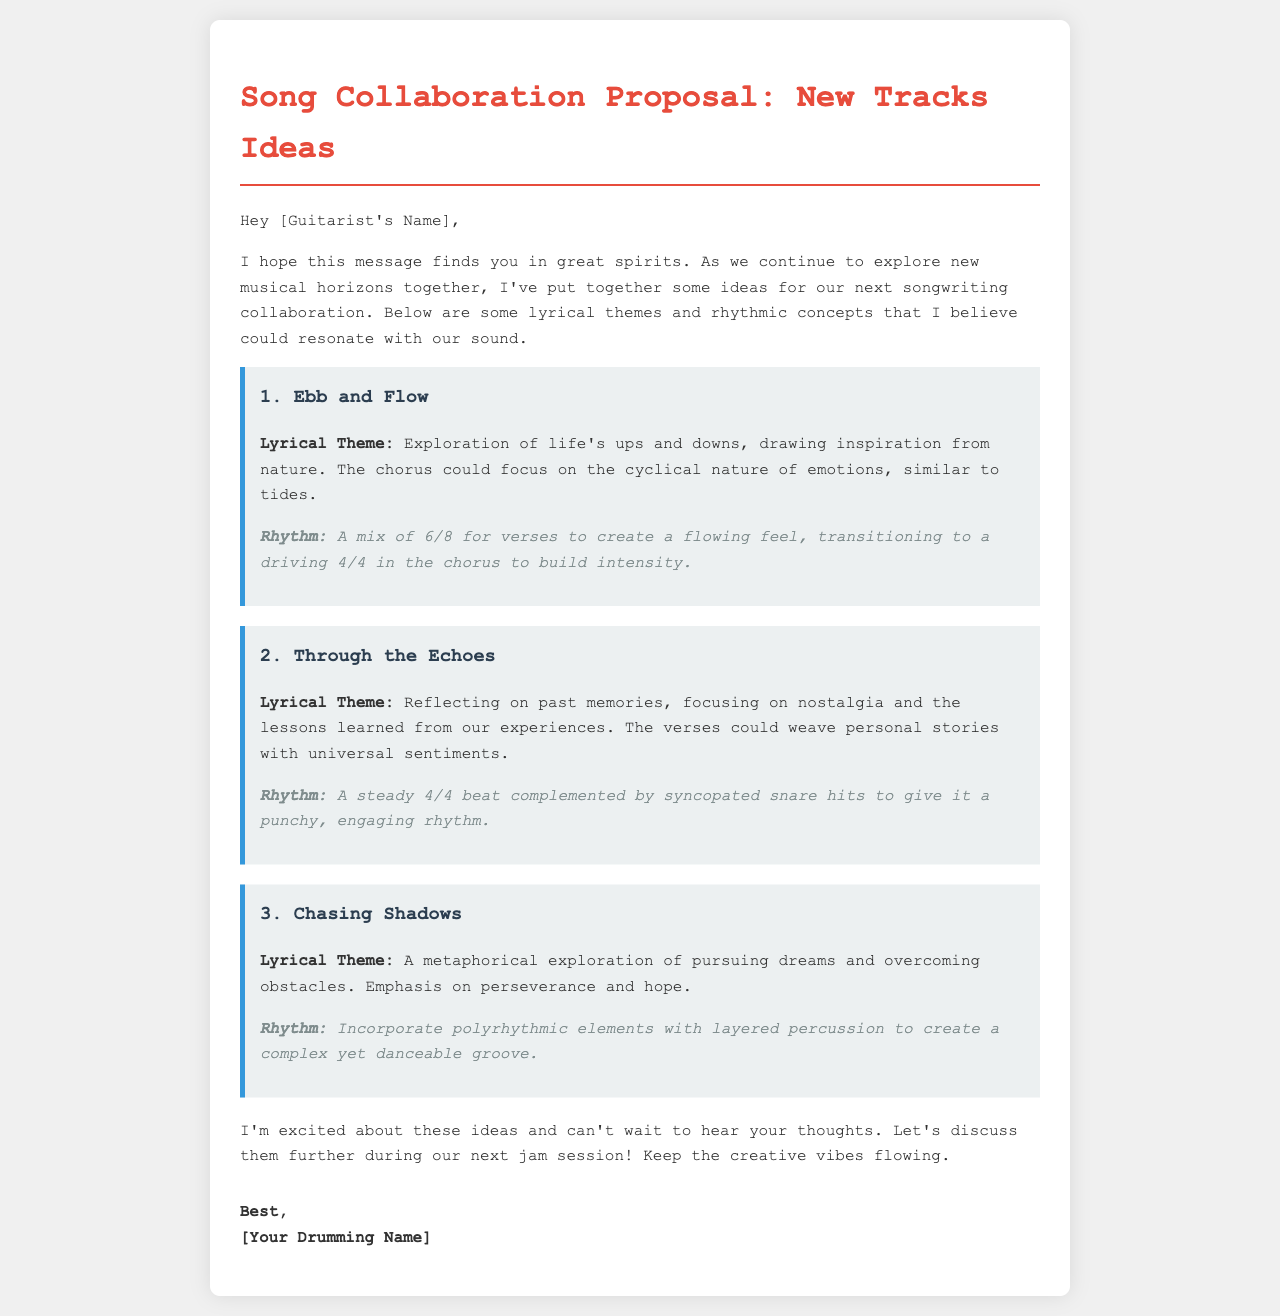What is the title of the document? The title of the document is presented at the top of the rendered HTML page.
Answer: Song Collaboration Proposal: New Tracks Ideas Who is the recipient of the email? The recipient of the email is mentioned at the beginning of the document.
Answer: [Guitarist's Name] What is the first lyrical theme proposed? The first lyrical theme is stated in the first idea of the document.
Answer: Ebb and Flow What type of rhythm is suggested for "Through the Echoes"? The rhythm for "Through the Echoes" is described in the second idea of the document.
Answer: A steady 4/4 beat How many lyrical themes are outlined in the proposal? The document lists three distinct lyrical themes for collaboration.
Answer: Three What is the suggested rhythm for "Chasing Shadows"? The rhythm for "Chasing Shadows" is found in the third idea of the document.
Answer: Polyrhythmic elements with layered percussion What closing sentiment does the sender express? The closing sentiment is indicated towards the end of the email.
Answer: Keep the creative vibes flowing What is the formatting style applied to the ideas in the document? The ideas are formatted with a specific CSS class that is defined in the document's style section.
Answer: Background color, border, and padding styles 